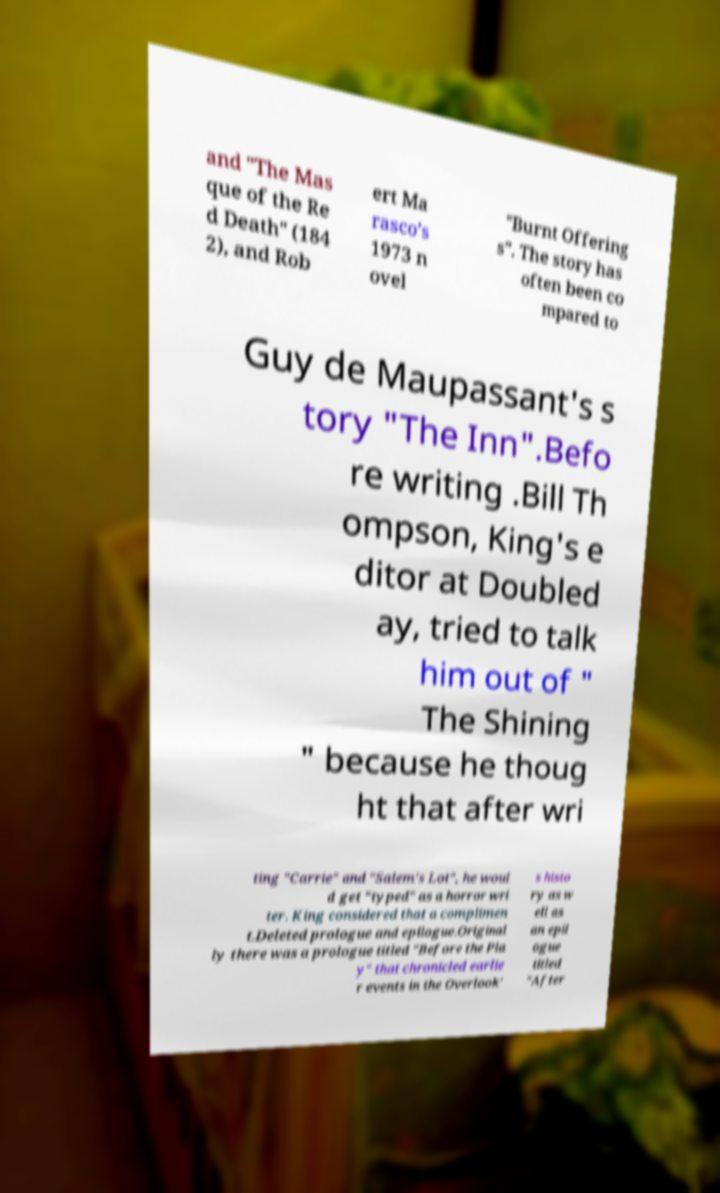Can you accurately transcribe the text from the provided image for me? and "The Mas que of the Re d Death" (184 2), and Rob ert Ma rasco's 1973 n ovel "Burnt Offering s". The story has often been co mpared to Guy de Maupassant's s tory "The Inn".Befo re writing .Bill Th ompson, King's e ditor at Doubled ay, tried to talk him out of " The Shining " because he thoug ht that after wri ting "Carrie" and "Salem's Lot", he woul d get "typed" as a horror wri ter. King considered that a complimen t.Deleted prologue and epilogue.Original ly there was a prologue titled "Before the Pla y" that chronicled earlie r events in the Overlook' s histo ry as w ell as an epil ogue titled "After 